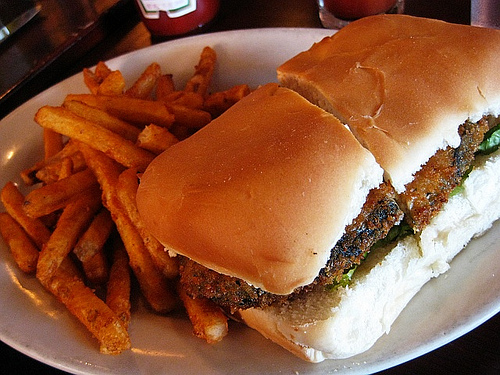<image>Which of these foods is grown in the ground? I don't know which food is grown in the ground. But it can be potatoes. Which of these foods is grown in the ground? Potatoes are grown in the ground. 